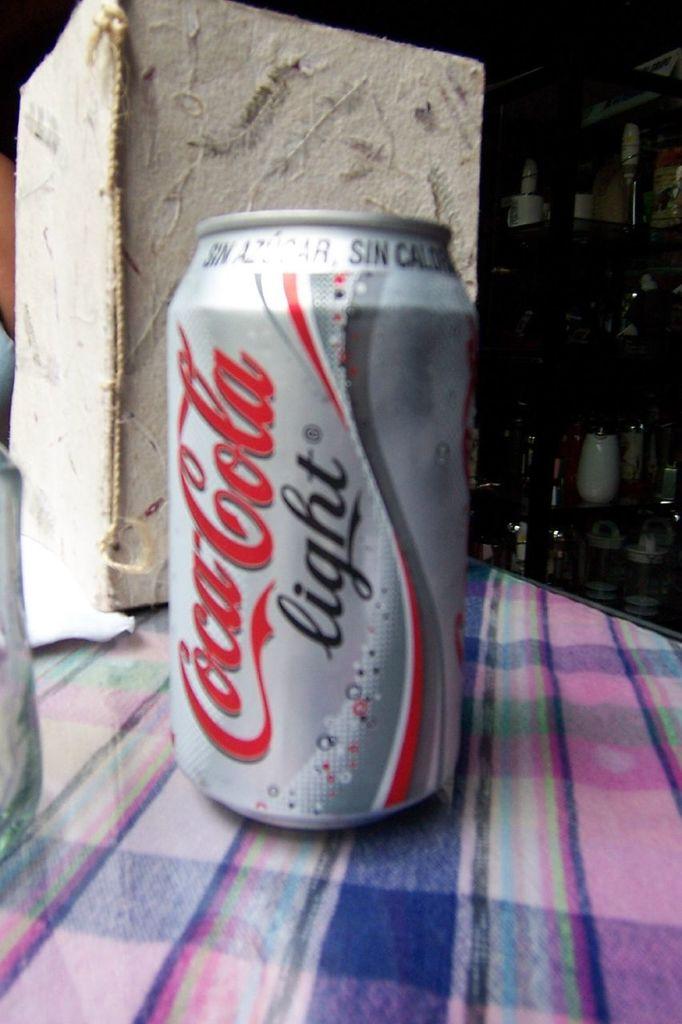What brand of soda is pictured?
Your answer should be very brief. Coca cola light. 